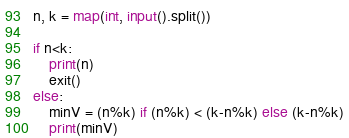Convert code to text. <code><loc_0><loc_0><loc_500><loc_500><_Python_>n, k = map(int, input().split())

if n<k:
    print(n)
    exit()
else:
    minV = (n%k) if (n%k) < (k-n%k) else (k-n%k)
    print(minV)</code> 